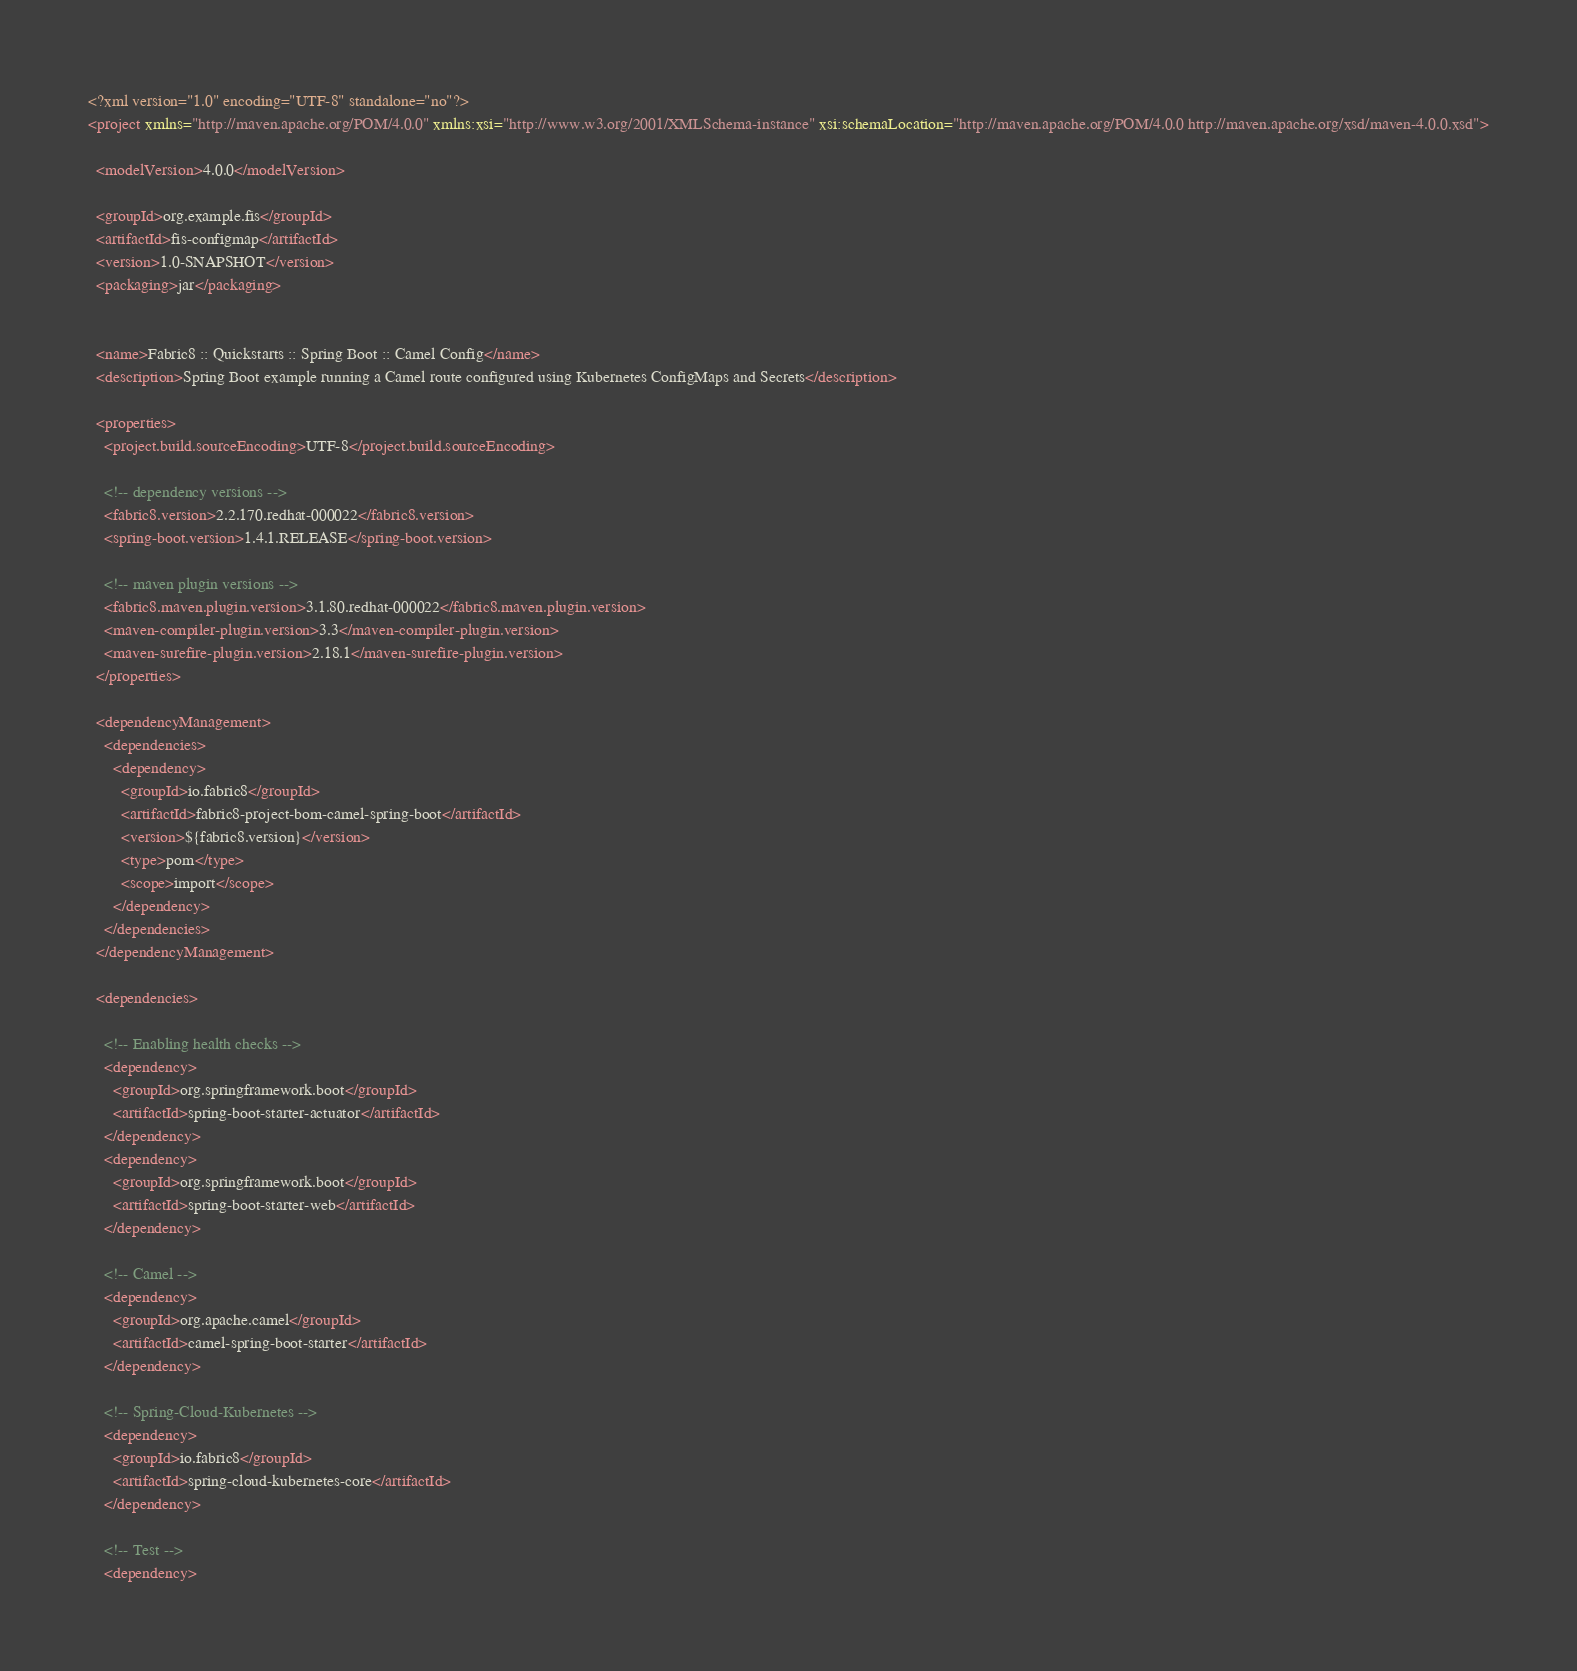Convert code to text. <code><loc_0><loc_0><loc_500><loc_500><_XML_><?xml version="1.0" encoding="UTF-8" standalone="no"?>
<project xmlns="http://maven.apache.org/POM/4.0.0" xmlns:xsi="http://www.w3.org/2001/XMLSchema-instance" xsi:schemaLocation="http://maven.apache.org/POM/4.0.0 http://maven.apache.org/xsd/maven-4.0.0.xsd">

  <modelVersion>4.0.0</modelVersion>

  <groupId>org.example.fis</groupId>
  <artifactId>fis-configmap</artifactId>
  <version>1.0-SNAPSHOT</version>
  <packaging>jar</packaging>


  <name>Fabric8 :: Quickstarts :: Spring Boot :: Camel Config</name>
  <description>Spring Boot example running a Camel route configured using Kubernetes ConfigMaps and Secrets</description>

  <properties>
    <project.build.sourceEncoding>UTF-8</project.build.sourceEncoding>

    <!-- dependency versions -->
    <fabric8.version>2.2.170.redhat-000022</fabric8.version>
    <spring-boot.version>1.4.1.RELEASE</spring-boot.version>

    <!-- maven plugin versions -->
    <fabric8.maven.plugin.version>3.1.80.redhat-000022</fabric8.maven.plugin.version>
    <maven-compiler-plugin.version>3.3</maven-compiler-plugin.version>
    <maven-surefire-plugin.version>2.18.1</maven-surefire-plugin.version>
  </properties>

  <dependencyManagement>
    <dependencies>
      <dependency>
        <groupId>io.fabric8</groupId>
        <artifactId>fabric8-project-bom-camel-spring-boot</artifactId>
        <version>${fabric8.version}</version>
        <type>pom</type>
        <scope>import</scope>
      </dependency>
    </dependencies>
  </dependencyManagement>

  <dependencies>

    <!-- Enabling health checks -->
    <dependency>
      <groupId>org.springframework.boot</groupId>
      <artifactId>spring-boot-starter-actuator</artifactId>
    </dependency>
    <dependency>
      <groupId>org.springframework.boot</groupId>
      <artifactId>spring-boot-starter-web</artifactId>
    </dependency>

    <!-- Camel -->
    <dependency>
      <groupId>org.apache.camel</groupId>
      <artifactId>camel-spring-boot-starter</artifactId>
    </dependency>

    <!-- Spring-Cloud-Kubernetes -->
    <dependency>
      <groupId>io.fabric8</groupId>
      <artifactId>spring-cloud-kubernetes-core</artifactId>
    </dependency>

    <!-- Test -->
    <dependency></code> 